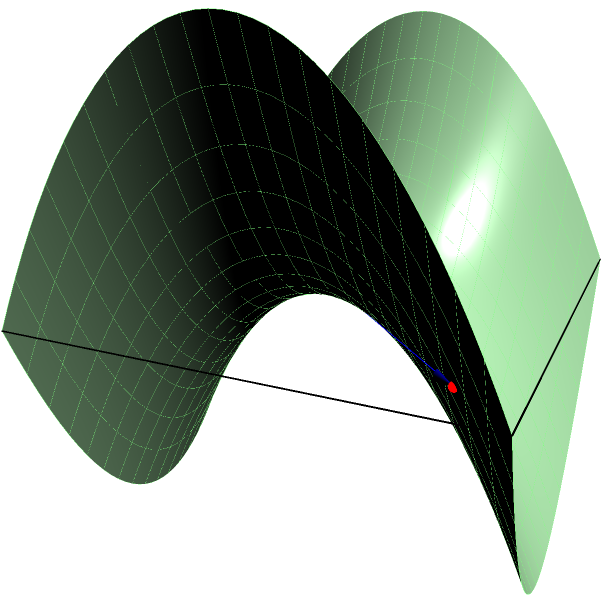On a saddle-shaped surface described by the equation $z = x^2 - y^2$, two points A(-1.5, -1.5, 0.75) and B(1.5, 1.5, 0.75) are marked. What is the nature of the shortest path (geodesic) between these two points, and how does it differ from the straight line path shown in blue? To analyze the shortest path (geodesic) between points A and B on this saddle-shaped surface:

1) Surface equation: The surface is defined by $z = x^2 - y^2$, which is a hyperbolic paraboloid or "saddle" shape.

2) Straight line vs. geodesic:
   - The blue line represents a straight line in 3D space, not the actual shortest path on the surface.
   - The true geodesic will follow the curvature of the surface.

3) Properties of geodesics on a saddle surface:
   - Geodesics tend to curve away from the center of the saddle.
   - They follow paths of steepest descent/ascent relative to the surface.

4) Path analysis:
   - The straight line passes through the center of the saddle (0, 0, 0).
   - The true geodesic will likely curve outward, avoiding the central point.

5) Curve characteristics:
   - The geodesic will form a more complex curve than the straight line.
   - It will have a longer path length in 3D space but shorter distance along the surface.

6) Practical implications:
   - In probability analysis, this illustrates how direct paths in parameter space may not be optimal when constraints (like the surface) are present.

The true geodesic path will be a curved line on the surface, bending away from the center of the saddle, unlike the straight line shown.
Answer: Curved path bending away from saddle center 